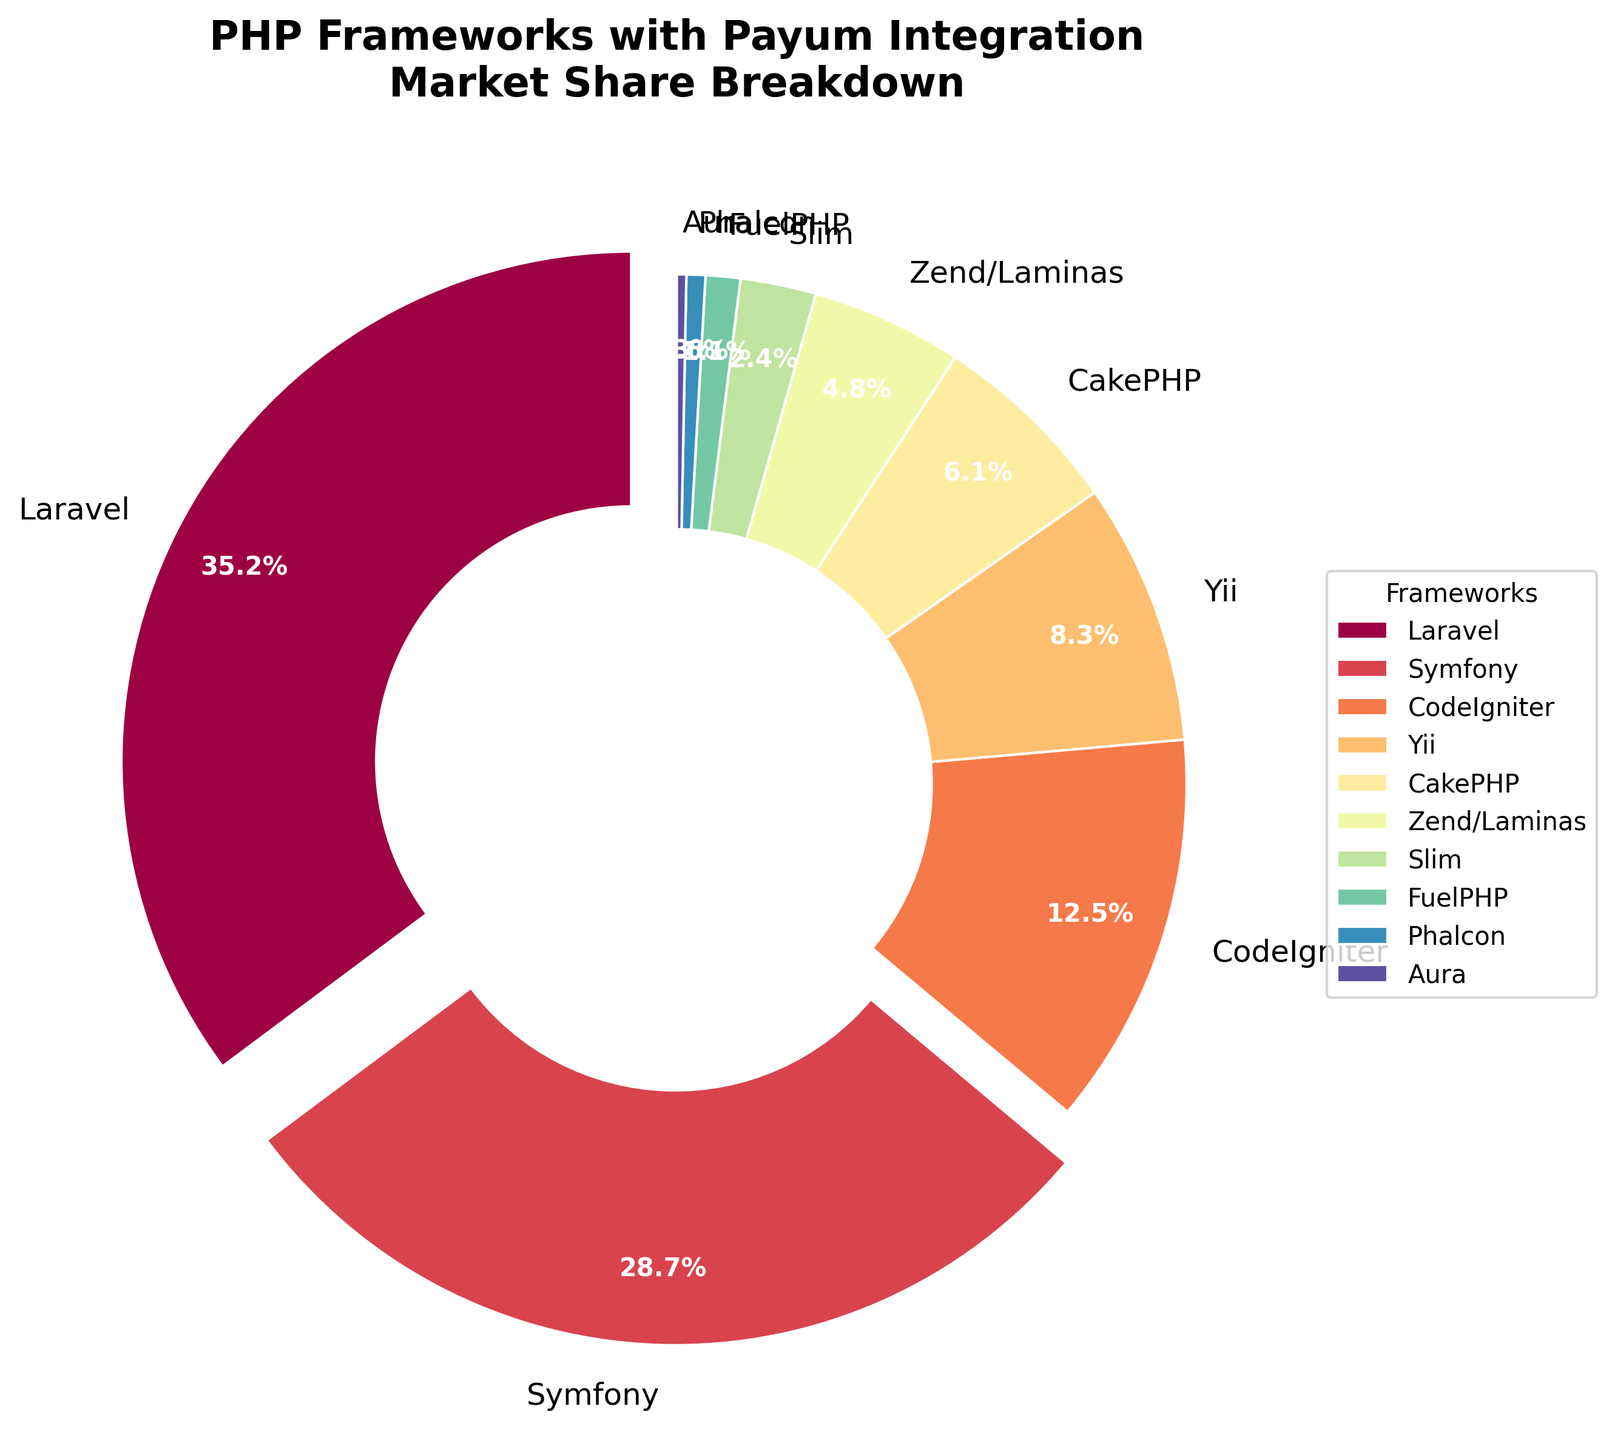Which PHP framework has the largest market share? The pie chart visually shows the market shares of various PHP frameworks. The largest slice corresponds to Laravel.
Answer: Laravel Which framework has the smallest market share? The smallest slice on the pie chart, representing the lowest percentage, corresponds to Aura.
Answer: Aura By how much does Laravel's market share exceed Symfony's? Laravel has a market share of 35.2%, while Symfony has 28.7%. The difference is calculated as 35.2% - 28.7% = 6.5%.
Answer: 6.5% Which frameworks have a market share greater than 10%? The slices representing frameworks with market shares above 10% are Laravel (35.2%), Symfony (28.7%), and CodeIgniter (12.5%).
Answer: Laravel, Symfony, CodeIgniter How does the combined market share of CakePHP and Zend/Laminas compare to Yii? CakePHP has a market share of 6.1%, and Zend/Laminas has 4.8%, summing to 10.9%. Yii has 8.3%. Since 10.9% > 8.3%, the combined market share of CakePHP and Zend/Laminas is greater than Yii's.
Answer: Combined share is greater What is the total market share of frameworks with slices colored in shades from blue to green? The colors corresponding to Slim (2.4%), FuelPHP (1.1%), Phalcon (0.6%), and Aura (0.3%) in the pie chart are in shades from blue to green. Adding these shares: 2.4% + 1.1% + 0.6% + 0.3% = 4.4%.
Answer: 4.4% Which framework has a slice highlighted with an explosion effect? The pie chart explodes the slice for frameworks with a market share greater than 20%. The only exploded slice corresponds to Laravel.
Answer: Laravel What percentage of market share do frameworks with a market share less than 2% collectively hold? Summing the percentages of FuelPHP (1.1%), Phalcon (0.6%), and Aura (0.3%) results in 1.1% + 0.6% + 0.3% = 2.0%.
Answer: 2.0% 